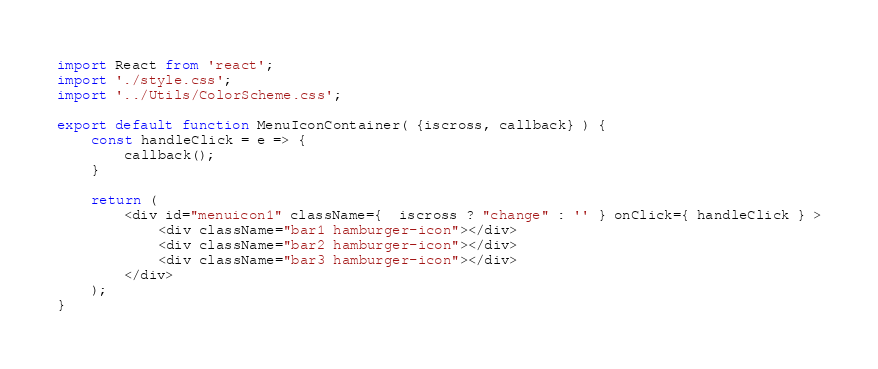<code> <loc_0><loc_0><loc_500><loc_500><_JavaScript_>import React from 'react';
import './style.css';
import '../Utils/ColorScheme.css';

export default function MenuIconContainer( {iscross, callback} ) {
	const handleClick = e => {
		callback();
	}
	
	return (
		<div id="menuicon1" className={  iscross ? "change" : '' } onClick={ handleClick } >
			<div className="bar1 hamburger-icon"></div>
			<div className="bar2 hamburger-icon"></div>
			<div className="bar3 hamburger-icon"></div>
		</div>
	);
}</code> 